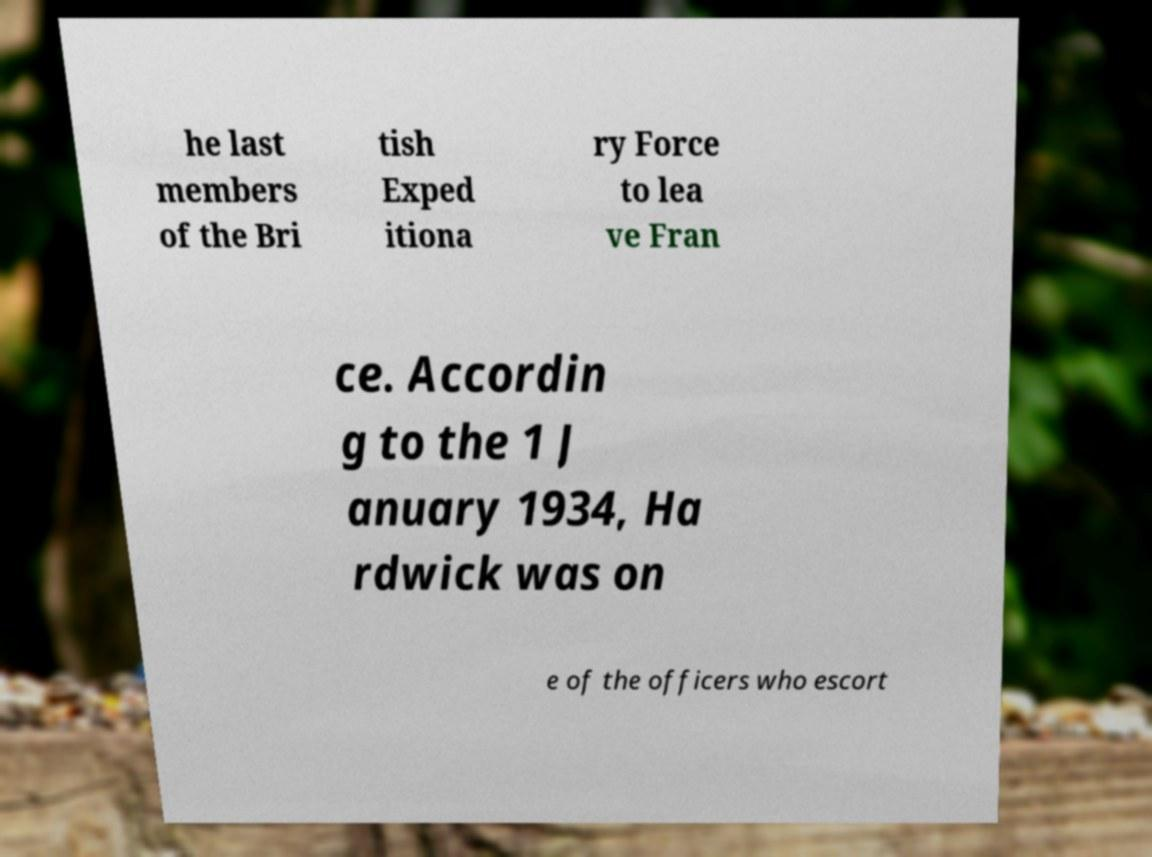There's text embedded in this image that I need extracted. Can you transcribe it verbatim? he last members of the Bri tish Exped itiona ry Force to lea ve Fran ce. Accordin g to the 1 J anuary 1934, Ha rdwick was on e of the officers who escort 